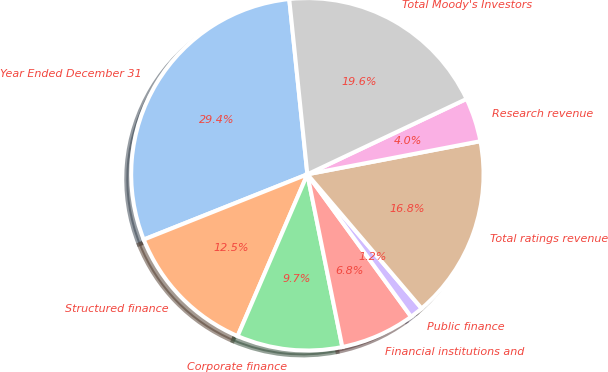Convert chart to OTSL. <chart><loc_0><loc_0><loc_500><loc_500><pie_chart><fcel>Year Ended December 31<fcel>Structured finance<fcel>Corporate finance<fcel>Financial institutions and<fcel>Public finance<fcel>Total ratings revenue<fcel>Research revenue<fcel>Total Moody's Investors<nl><fcel>29.4%<fcel>12.48%<fcel>9.66%<fcel>6.84%<fcel>1.21%<fcel>16.78%<fcel>4.03%<fcel>19.6%<nl></chart> 